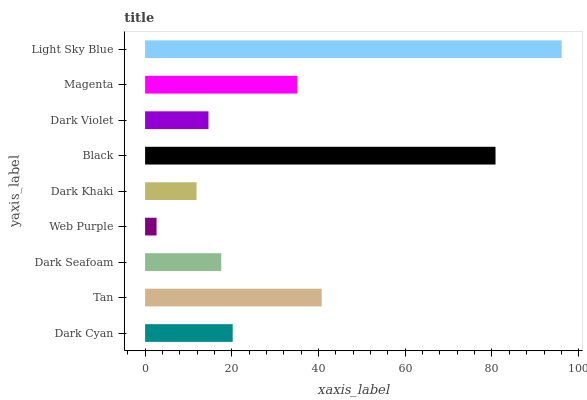Is Web Purple the minimum?
Answer yes or no. Yes. Is Light Sky Blue the maximum?
Answer yes or no. Yes. Is Tan the minimum?
Answer yes or no. No. Is Tan the maximum?
Answer yes or no. No. Is Tan greater than Dark Cyan?
Answer yes or no. Yes. Is Dark Cyan less than Tan?
Answer yes or no. Yes. Is Dark Cyan greater than Tan?
Answer yes or no. No. Is Tan less than Dark Cyan?
Answer yes or no. No. Is Dark Cyan the high median?
Answer yes or no. Yes. Is Dark Cyan the low median?
Answer yes or no. Yes. Is Dark Violet the high median?
Answer yes or no. No. Is Black the low median?
Answer yes or no. No. 